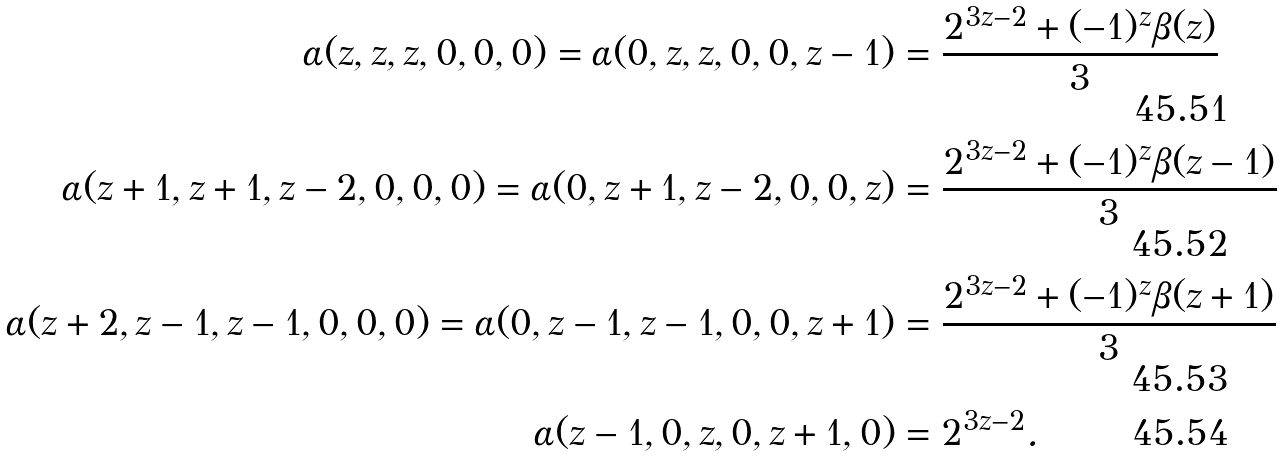Convert formula to latex. <formula><loc_0><loc_0><loc_500><loc_500>\alpha ( z , z , z , 0 , 0 , 0 ) = \alpha ( 0 , z , z , 0 , 0 , z - 1 ) & = \frac { 2 ^ { 3 z - 2 } + ( - 1 ) ^ { z } \beta ( z ) } { 3 } \\ \alpha ( z + 1 , z + 1 , z - 2 , 0 , 0 , 0 ) = \alpha ( 0 , z + 1 , z - 2 , 0 , 0 , z ) & = \frac { 2 ^ { 3 z - 2 } + ( - 1 ) ^ { z } \beta ( z - 1 ) } { 3 } \\ \alpha ( z + 2 , z - 1 , z - 1 , 0 , 0 , 0 ) = \alpha ( 0 , z - 1 , z - 1 , 0 , 0 , z + 1 ) & = \frac { 2 ^ { 3 z - 2 } + ( - 1 ) ^ { z } \beta ( z + 1 ) } { 3 } \\ \alpha ( z - 1 , 0 , z , 0 , z + 1 , 0 ) & = 2 ^ { 3 z - 2 } .</formula> 